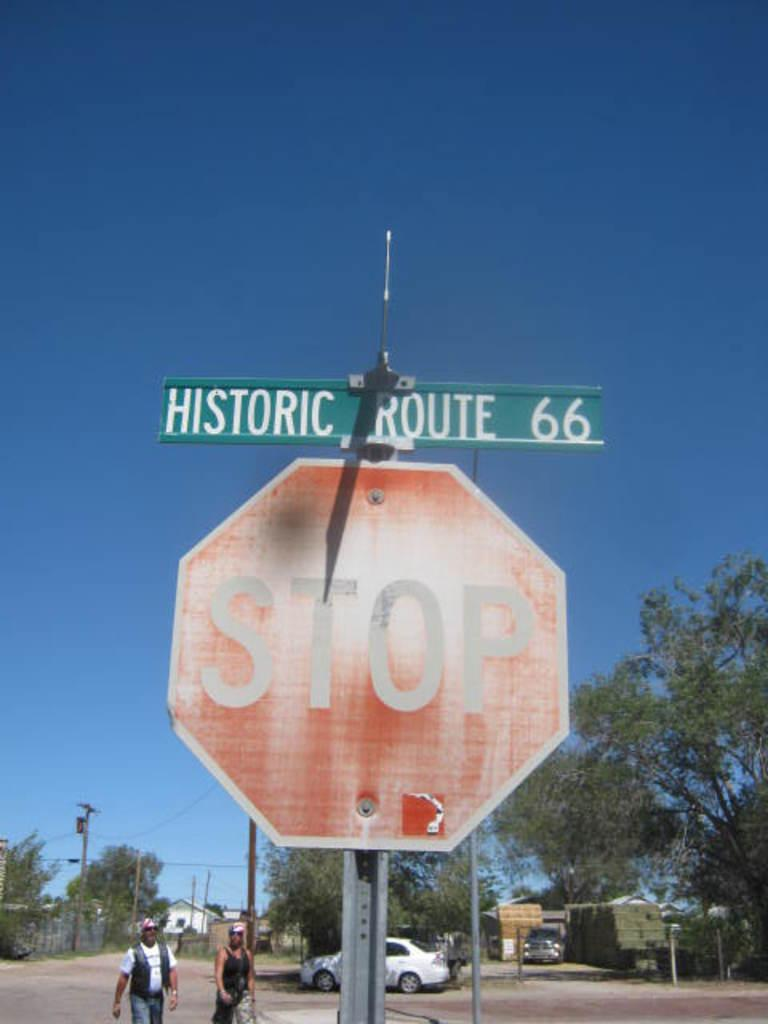<image>
Render a clear and concise summary of the photo. A stop sign with a street sign that reads historic route 66 on the top. 